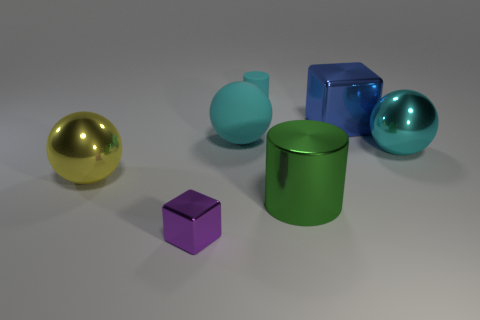Are there more blocks right of the large metallic cylinder than purple metallic objects that are behind the cyan cylinder?
Provide a succinct answer. Yes. What number of other things are the same size as the green metal cylinder?
Offer a terse response. 4. How big is the shiny block that is to the left of the tiny thing behind the large green metallic cylinder?
Your answer should be very brief. Small. What number of large things are cyan things or purple metal balls?
Make the answer very short. 2. What is the size of the metallic block that is in front of the cyan thing left of the small object to the right of the large cyan matte sphere?
Provide a short and direct response. Small. Is there anything else that is the same color as the matte ball?
Ensure brevity in your answer.  Yes. There is a large thing that is in front of the big shiny thing that is to the left of the cube in front of the big cyan matte ball; what is its material?
Give a very brief answer. Metal. Do the big yellow metal object and the green metallic thing have the same shape?
Your answer should be very brief. No. Is there anything else that is made of the same material as the big yellow sphere?
Provide a short and direct response. Yes. How many metal objects are to the left of the tiny cylinder and behind the large cylinder?
Provide a short and direct response. 1. 